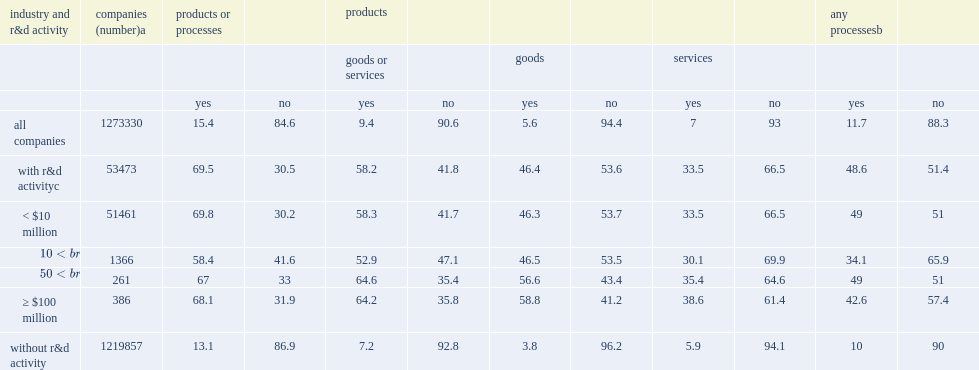How many for-profit companies performed or funded r&d in 2014? 1273330.0. What was the number of the estimated 1.3 million for-profit companies performed or funded r&d in 2014? 53473.0. How many percent of companies with less than $10 million of r&d activity reported product or process innovations? 69.8. How many percent of the companies with over $100 million in r&d activity reported such innovations? 68.1. Could you parse the entire table as a dict? {'header': ['industry and r&d activity', 'companies (number)a', 'products or processes', '', 'products', '', '', '', '', '', 'any processesb', ''], 'rows': [['', '', '', '', 'goods or services', '', 'goods', '', 'services', '', '', ''], ['', '', 'yes', 'no', 'yes', 'no', 'yes', 'no', 'yes', 'no', 'yes', 'no'], ['all companies', '1273330', '15.4', '84.6', '9.4', '90.6', '5.6', '94.4', '7', '93', '11.7', '88.3'], ['with r&d activityc', '53473', '69.5', '30.5', '58.2', '41.8', '46.4', '53.6', '33.5', '66.5', '48.6', '51.4'], ['< $10 million', '51461', '69.8', '30.2', '58.3', '41.7', '46.3', '53.7', '33.5', '66.5', '49', '51'], ['≥ $10 million but < $50 million', '1366', '58.4', '41.6', '52.9', '47.1', '46.5', '53.5', '30.1', '69.9', '34.1', '65.9'], ['≥ $50 million but < $100 million', '261', '67', '33', '64.6', '35.4', '56.6', '43.4', '35.4', '64.6', '49', '51'], ['≥ $100 million', '386', '68.1', '31.9', '64.2', '35.8', '58.8', '41.2', '38.6', '61.4', '42.6', '57.4'], ['without r&d activity', '1219857', '13.1', '86.9', '7.2', '92.8', '3.8', '96.2', '5.9', '94.1', '10', '90']]} 